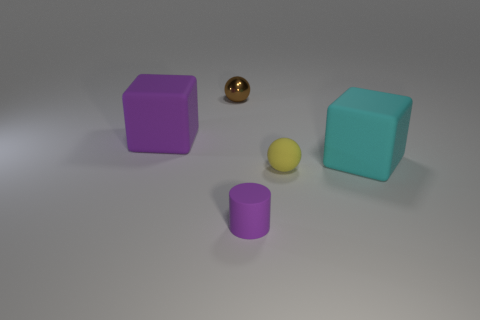Add 1 brown metal balls. How many objects exist? 6 Subtract all spheres. How many objects are left? 3 Add 4 brown balls. How many brown balls exist? 5 Subtract 0 brown blocks. How many objects are left? 5 Subtract all cyan blocks. Subtract all small metal objects. How many objects are left? 3 Add 2 metallic balls. How many metallic balls are left? 3 